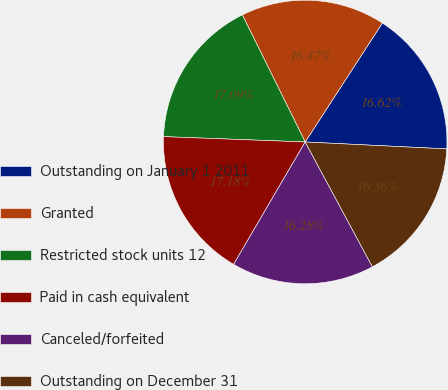Convert chart to OTSL. <chart><loc_0><loc_0><loc_500><loc_500><pie_chart><fcel>Outstanding on January 1 2011<fcel>Granted<fcel>Restricted stock units 12<fcel>Paid in cash equivalent<fcel>Canceled/forfeited<fcel>Outstanding on December 31<nl><fcel>16.62%<fcel>16.47%<fcel>17.09%<fcel>17.18%<fcel>16.28%<fcel>16.36%<nl></chart> 